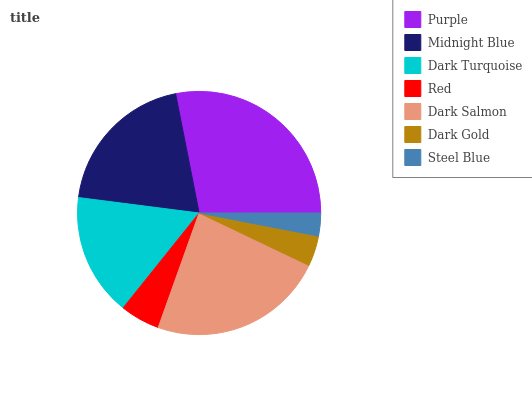Is Steel Blue the minimum?
Answer yes or no. Yes. Is Purple the maximum?
Answer yes or no. Yes. Is Midnight Blue the minimum?
Answer yes or no. No. Is Midnight Blue the maximum?
Answer yes or no. No. Is Purple greater than Midnight Blue?
Answer yes or no. Yes. Is Midnight Blue less than Purple?
Answer yes or no. Yes. Is Midnight Blue greater than Purple?
Answer yes or no. No. Is Purple less than Midnight Blue?
Answer yes or no. No. Is Dark Turquoise the high median?
Answer yes or no. Yes. Is Dark Turquoise the low median?
Answer yes or no. Yes. Is Dark Gold the high median?
Answer yes or no. No. Is Dark Salmon the low median?
Answer yes or no. No. 